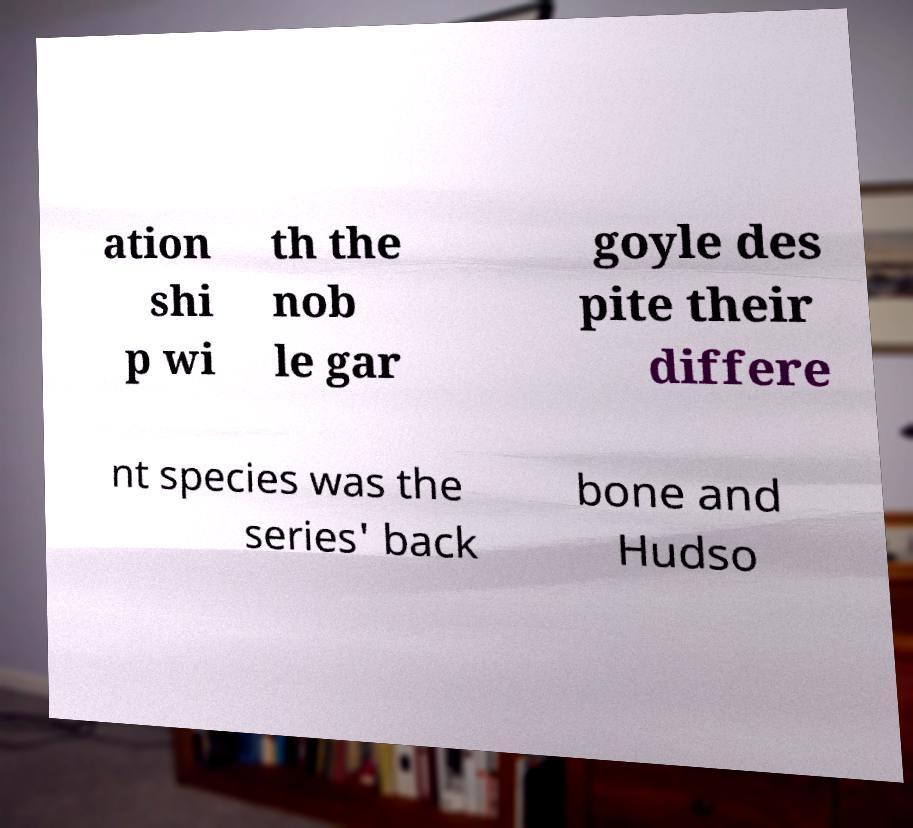I need the written content from this picture converted into text. Can you do that? ation shi p wi th the nob le gar goyle des pite their differe nt species was the series' back bone and Hudso 